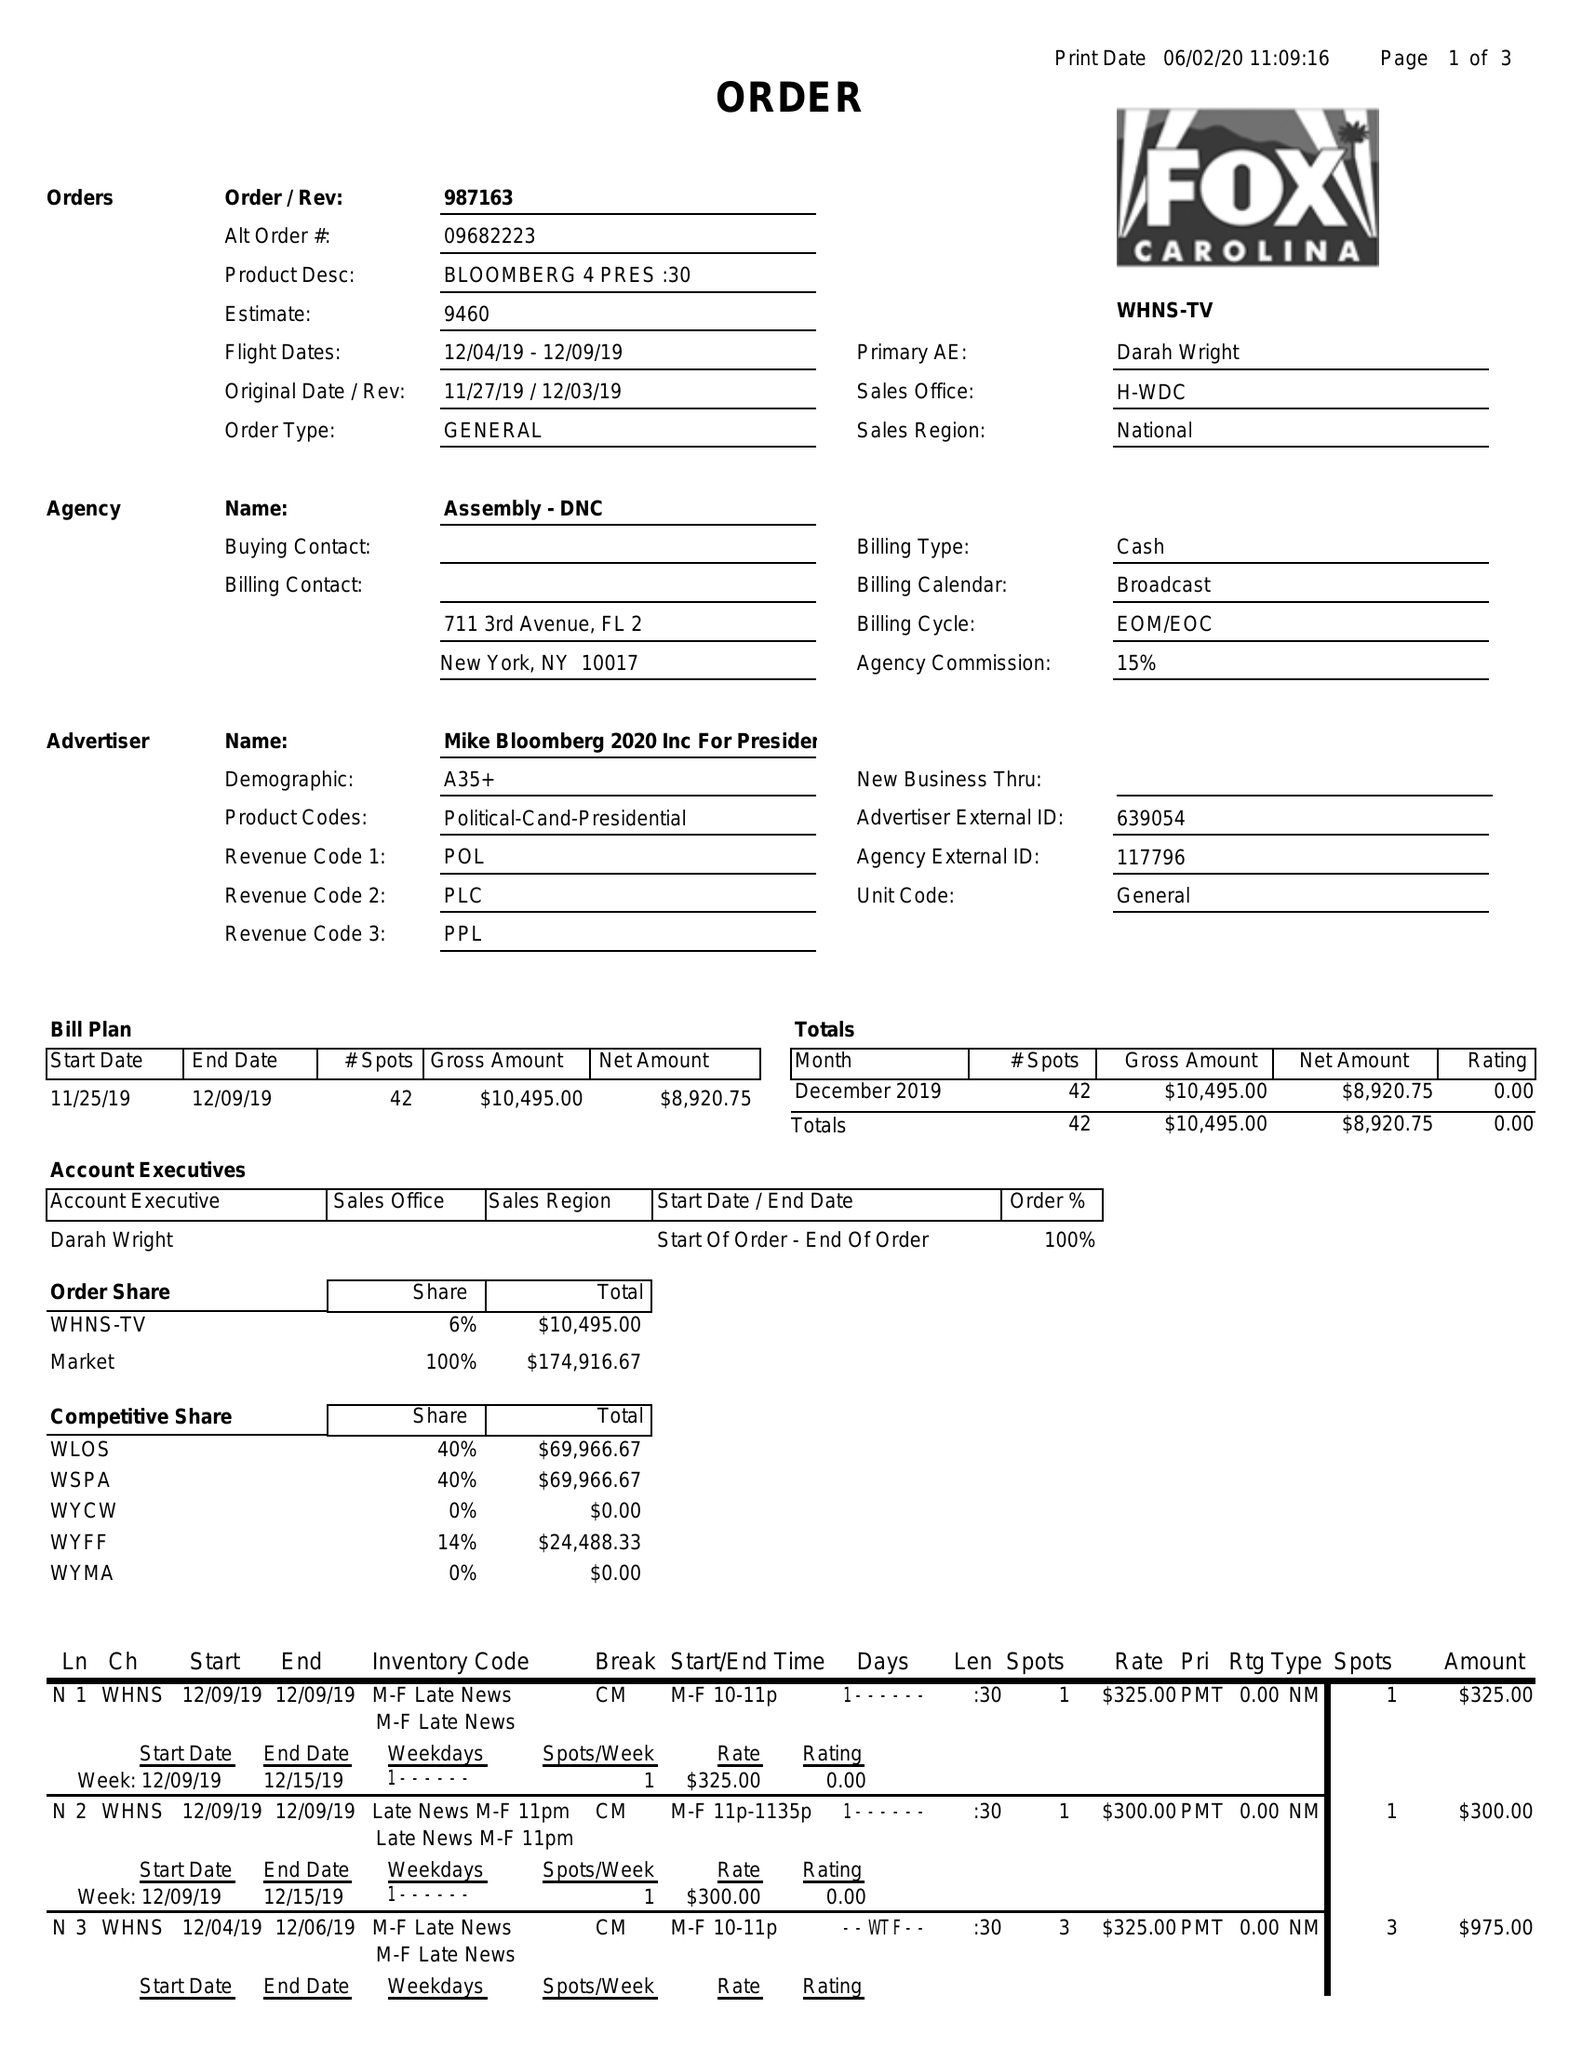What is the value for the flight_to?
Answer the question using a single word or phrase. 12/09/19 